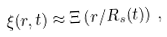<formula> <loc_0><loc_0><loc_500><loc_500>\xi ( r , t ) \approx \Xi \left ( r / R _ { s } ( t ) \right ) \, ,</formula> 